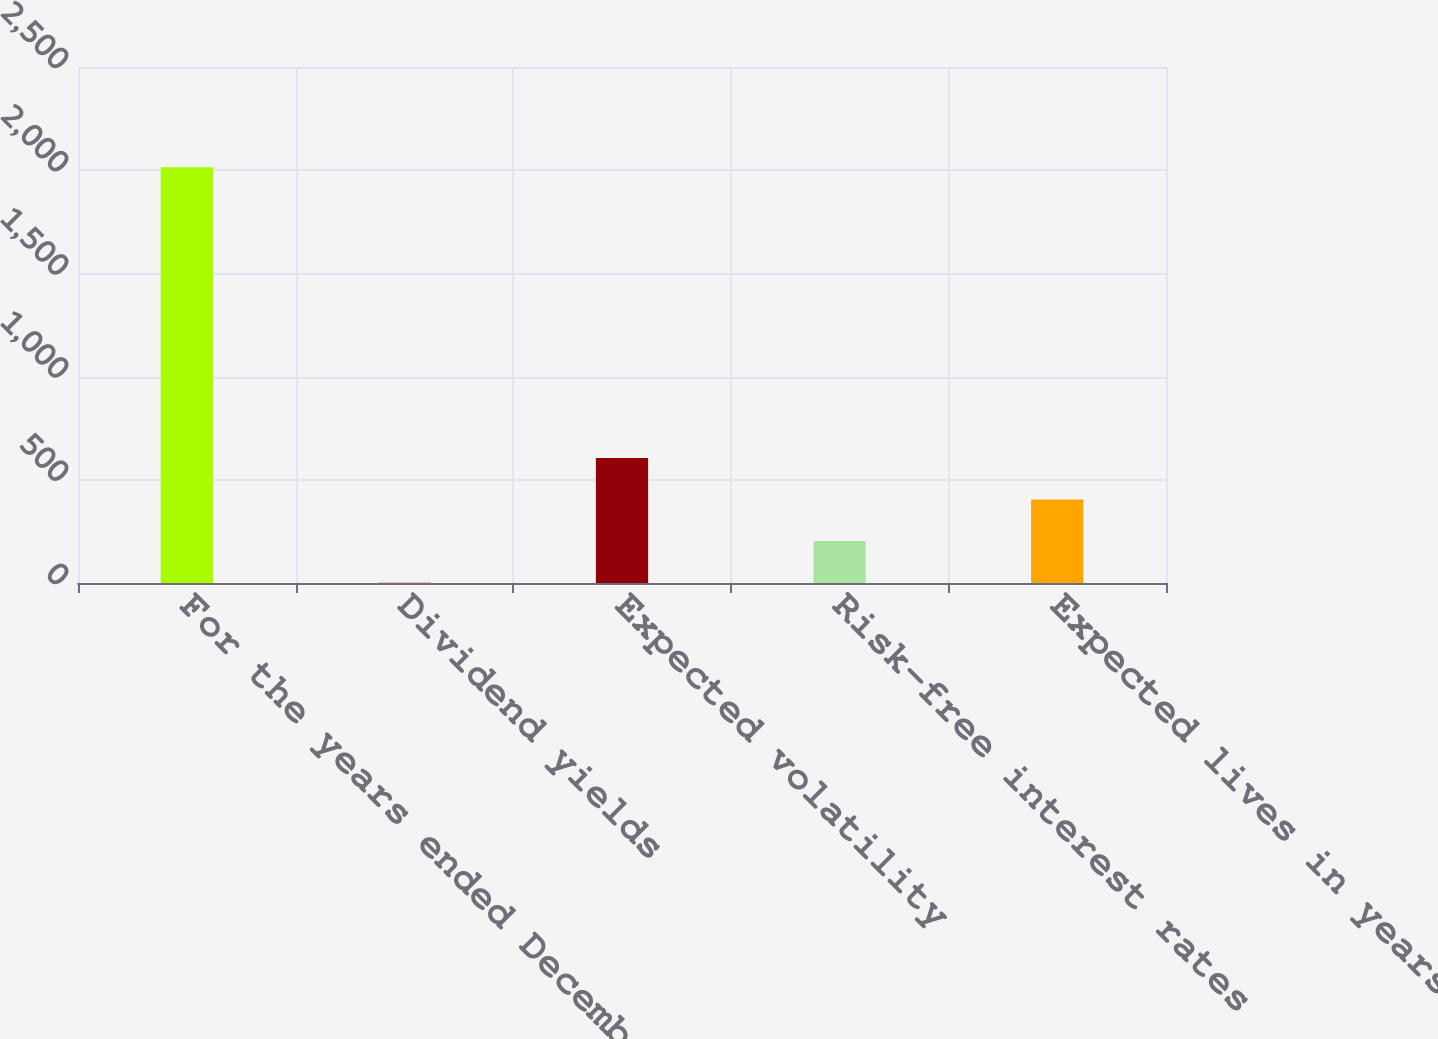<chart> <loc_0><loc_0><loc_500><loc_500><bar_chart><fcel>For the years ended December<fcel>Dividend yields<fcel>Expected volatility<fcel>Risk-free interest rates<fcel>Expected lives in years<nl><fcel>2014<fcel>2<fcel>605.6<fcel>203.2<fcel>404.4<nl></chart> 